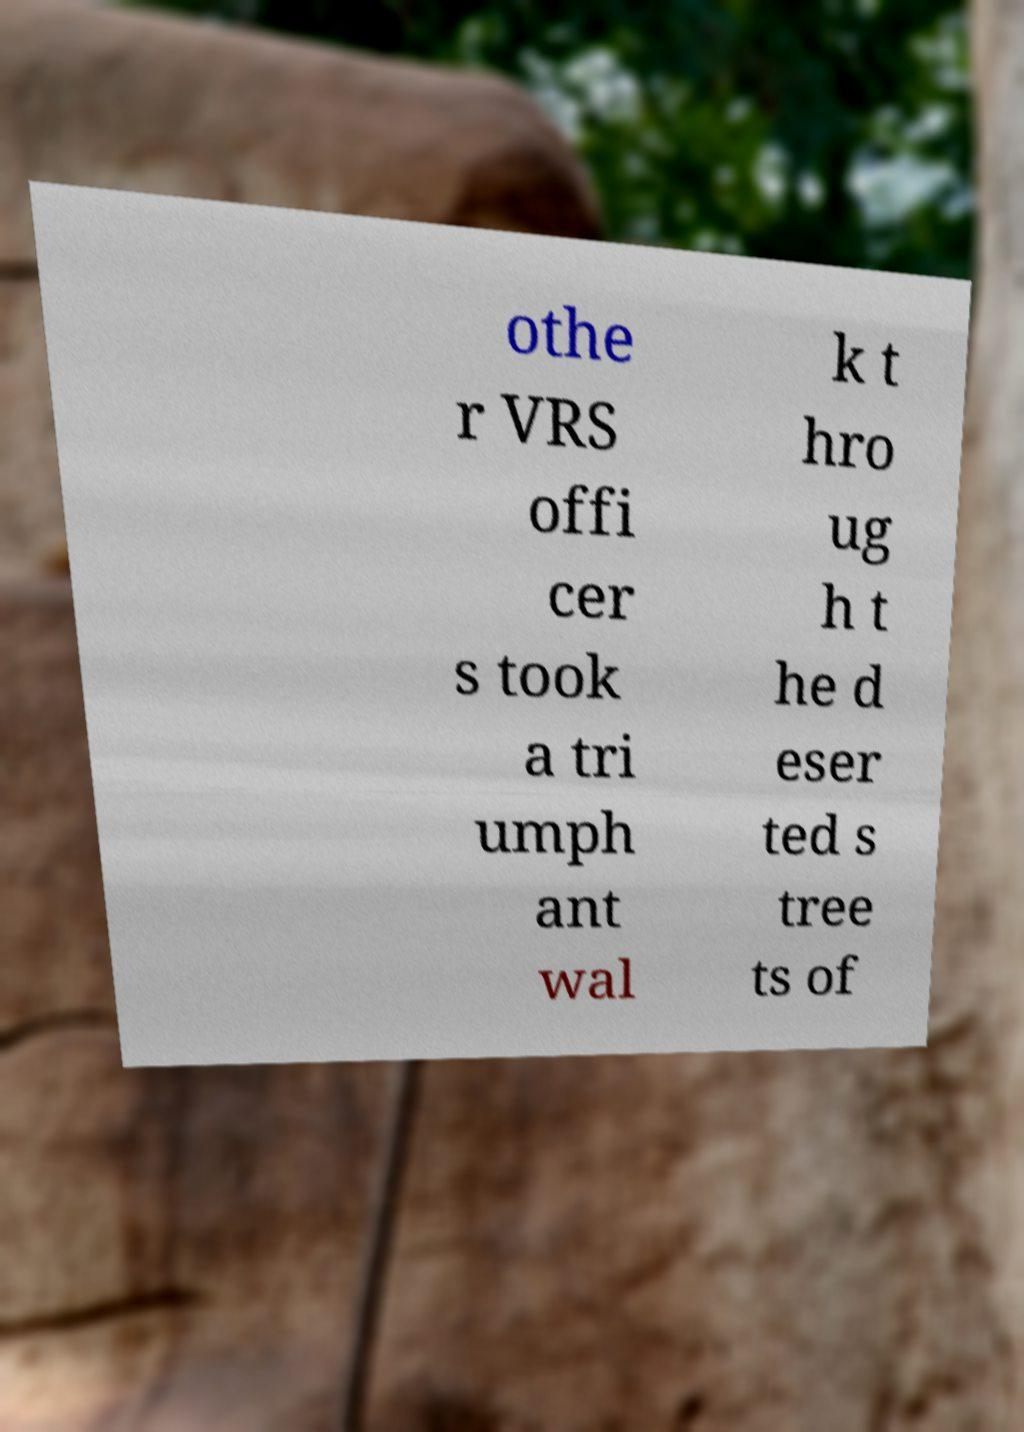There's text embedded in this image that I need extracted. Can you transcribe it verbatim? othe r VRS offi cer s took a tri umph ant wal k t hro ug h t he d eser ted s tree ts of 